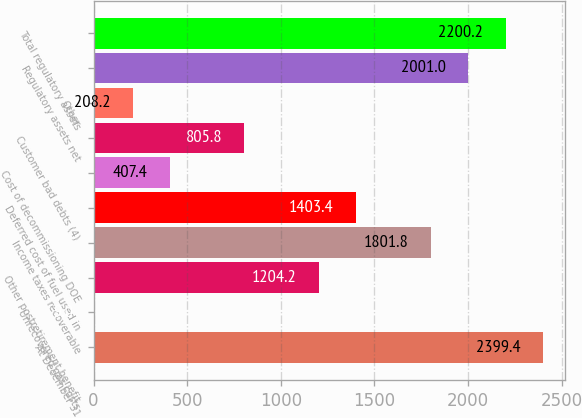Convert chart to OTSL. <chart><loc_0><loc_0><loc_500><loc_500><bar_chart><fcel>At December 31<fcel>Unrecovered gas costs<fcel>Other postretirement benefit<fcel>Income taxes recoverable<fcel>Deferred cost of fuel used in<fcel>Cost of decommissioning DOE<fcel>Customer bad debts (4)<fcel>Other<fcel>Regulatory assets net<fcel>Total regulatory assets<nl><fcel>2399.4<fcel>9<fcel>1204.2<fcel>1801.8<fcel>1403.4<fcel>407.4<fcel>805.8<fcel>208.2<fcel>2001<fcel>2200.2<nl></chart> 